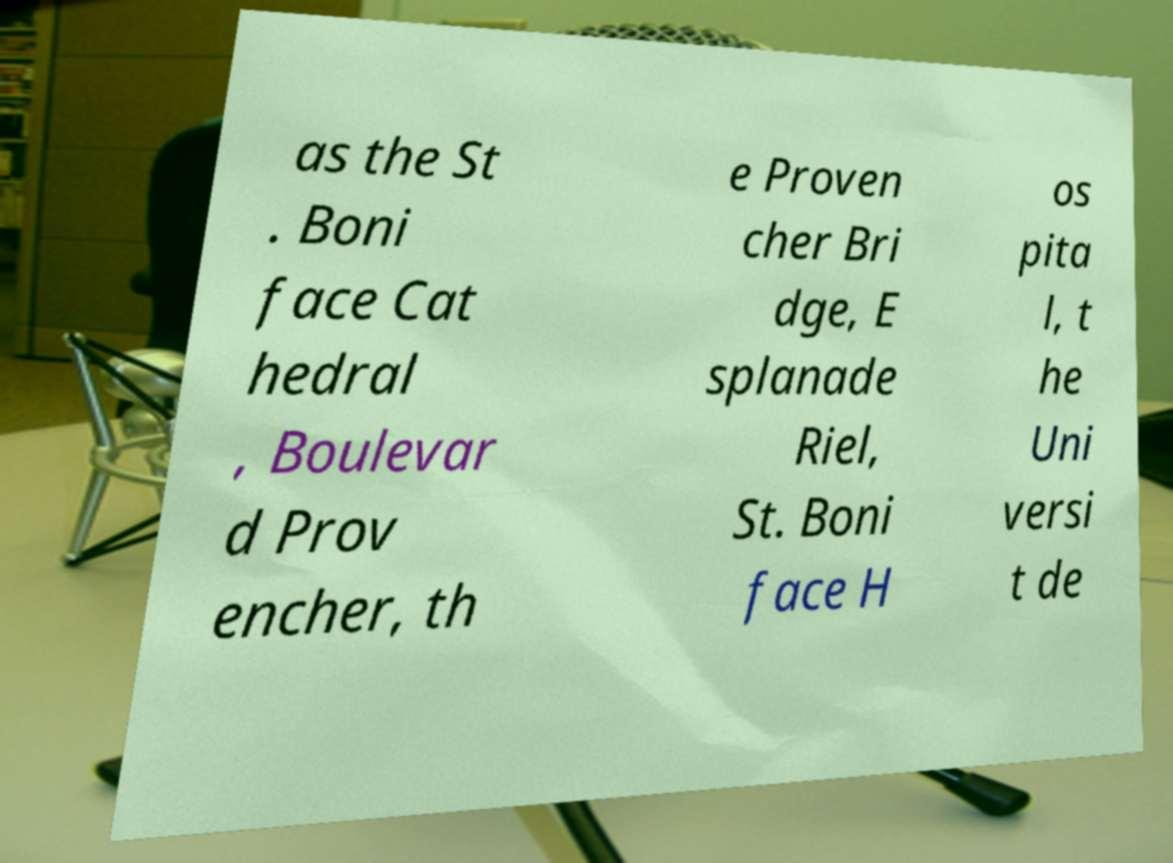Could you extract and type out the text from this image? as the St . Boni face Cat hedral , Boulevar d Prov encher, th e Proven cher Bri dge, E splanade Riel, St. Boni face H os pita l, t he Uni versi t de 